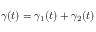Convert formula to latex. <formula><loc_0><loc_0><loc_500><loc_500>\gamma ( t ) = \gamma _ { 1 } ( t ) + \gamma _ { 2 } ( t )</formula> 